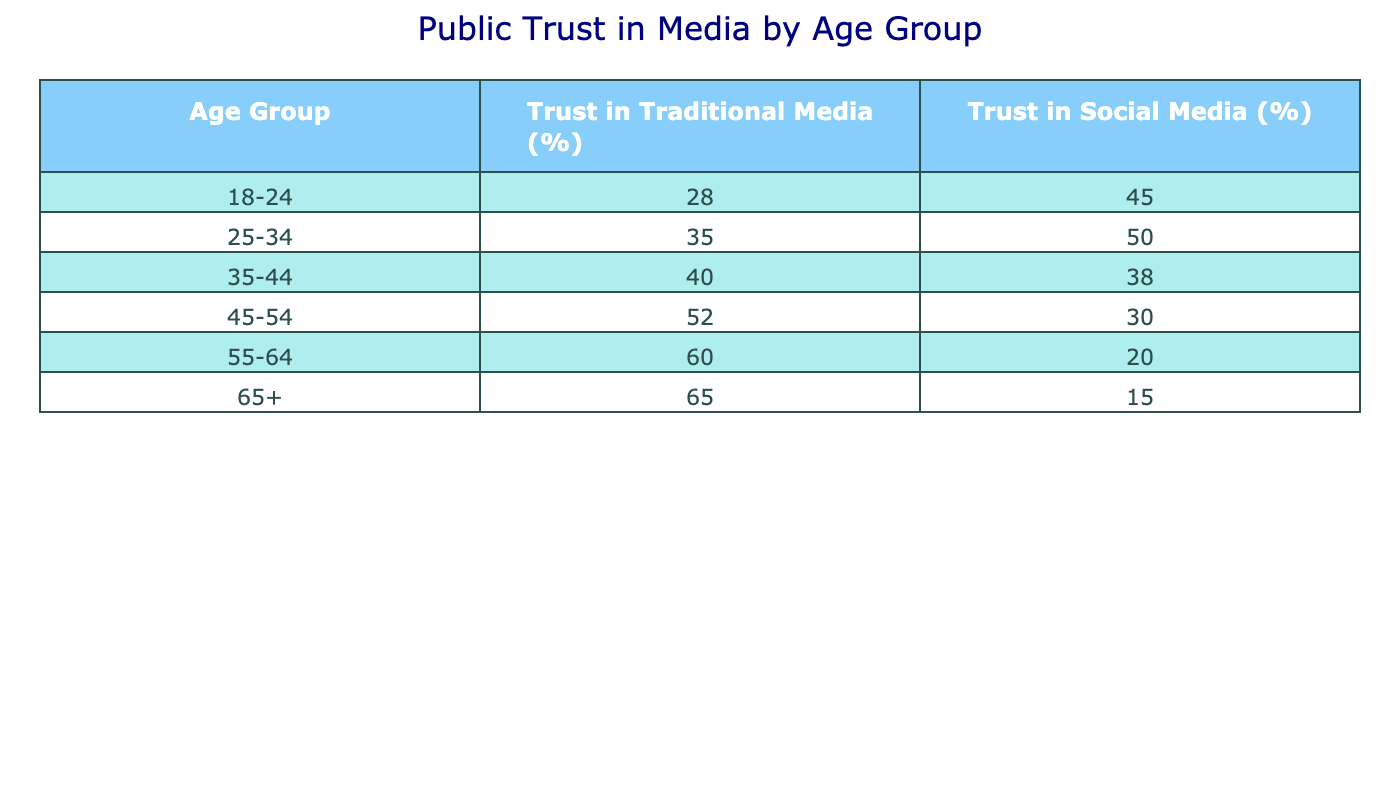What age group has the highest trust in traditional media? Looking at the values for "Trust in Traditional Media (%)" in the table, the age group "65+" has a value of 65%, which is the highest compared to other age groups.
Answer: 65+ What is the trust percentage in traditional media for the age group 45-54? The value for the age group "45-54" in the "Trust in Traditional Media (%)" column is 52%.
Answer: 52% Are there more people in the 18-24 age group who trust social media than traditional media? In the age group "18-24", the trust in social media is 45%, while the trust in traditional media is 28%. Since 45% is greater than 28%, the answer is yes.
Answer: Yes What is the average trust percentage in traditional media across all age groups? To find the average, add up the trust percentages: 28 + 35 + 40 + 52 + 60 + 65 = 280. Then, divide by the number of age groups (6): 280 / 6 = 46.67%.
Answer: 46.67% Which age group shows the largest difference in trust levels between traditional media and social media? Calculate the differences for each age group: 18-24 (17), 25-34 (15), 35-44 (2), 45-54 (22), 55-64 (40), and 65+ (50). The largest difference is between the age group "55-64", which shows a difference of 40%.
Answer: 55-64 Do individuals aged 35-44 trust traditional media more than those aged 25-34? The trust percentage for "35-44" is 40%, and for "25-34" it is 35%. Since 40% is greater than 35%, the answer is yes.
Answer: Yes What is the total percentage of trust in social media for the age group 55-64? The trust percentage for the "55-64" age group in "Trust in Social Media (%)" is 20%.
Answer: 20% Is there a consistent increase in trust for traditional media as age increases from 18-24 to 65+? The values for traditional media are 28%, 35%, 40%, 52%, 60%, and 65%. There is a consistent increase in these values, indicating a positive relationship.
Answer: Yes 